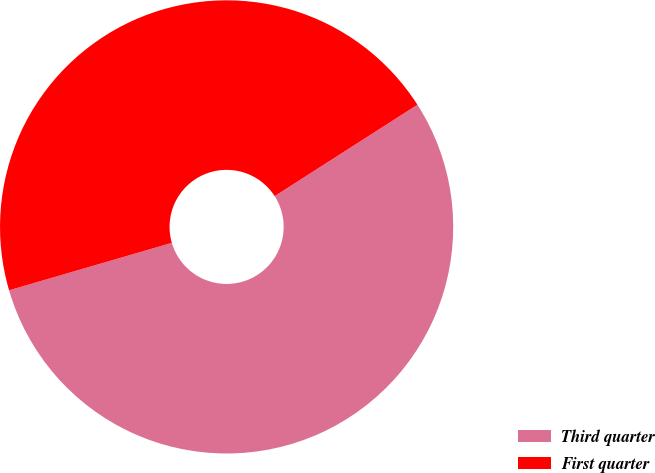Convert chart. <chart><loc_0><loc_0><loc_500><loc_500><pie_chart><fcel>Third quarter<fcel>First quarter<nl><fcel>54.55%<fcel>45.45%<nl></chart> 